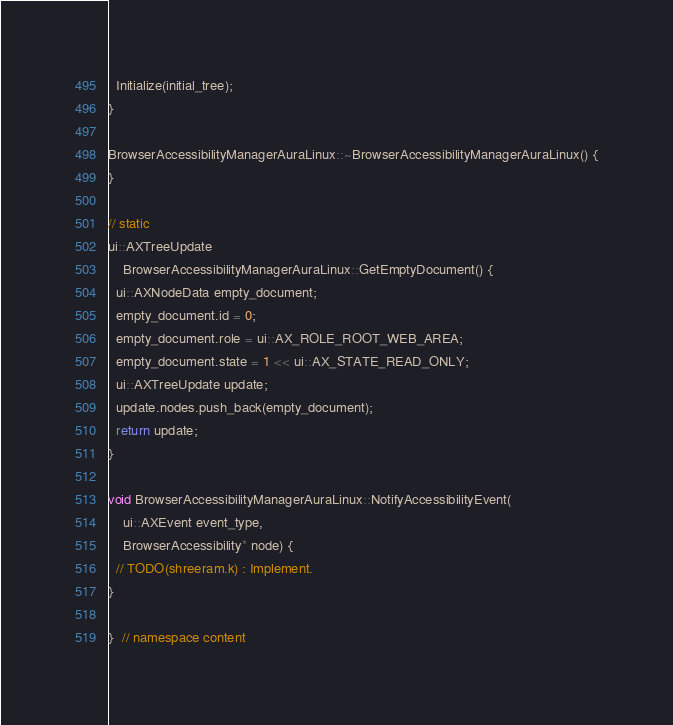Convert code to text. <code><loc_0><loc_0><loc_500><loc_500><_C++_>  Initialize(initial_tree);
}

BrowserAccessibilityManagerAuraLinux::~BrowserAccessibilityManagerAuraLinux() {
}

// static
ui::AXTreeUpdate
    BrowserAccessibilityManagerAuraLinux::GetEmptyDocument() {
  ui::AXNodeData empty_document;
  empty_document.id = 0;
  empty_document.role = ui::AX_ROLE_ROOT_WEB_AREA;
  empty_document.state = 1 << ui::AX_STATE_READ_ONLY;
  ui::AXTreeUpdate update;
  update.nodes.push_back(empty_document);
  return update;
}

void BrowserAccessibilityManagerAuraLinux::NotifyAccessibilityEvent(
    ui::AXEvent event_type,
    BrowserAccessibility* node) {
  // TODO(shreeram.k) : Implement.
}

}  // namespace content
</code> 